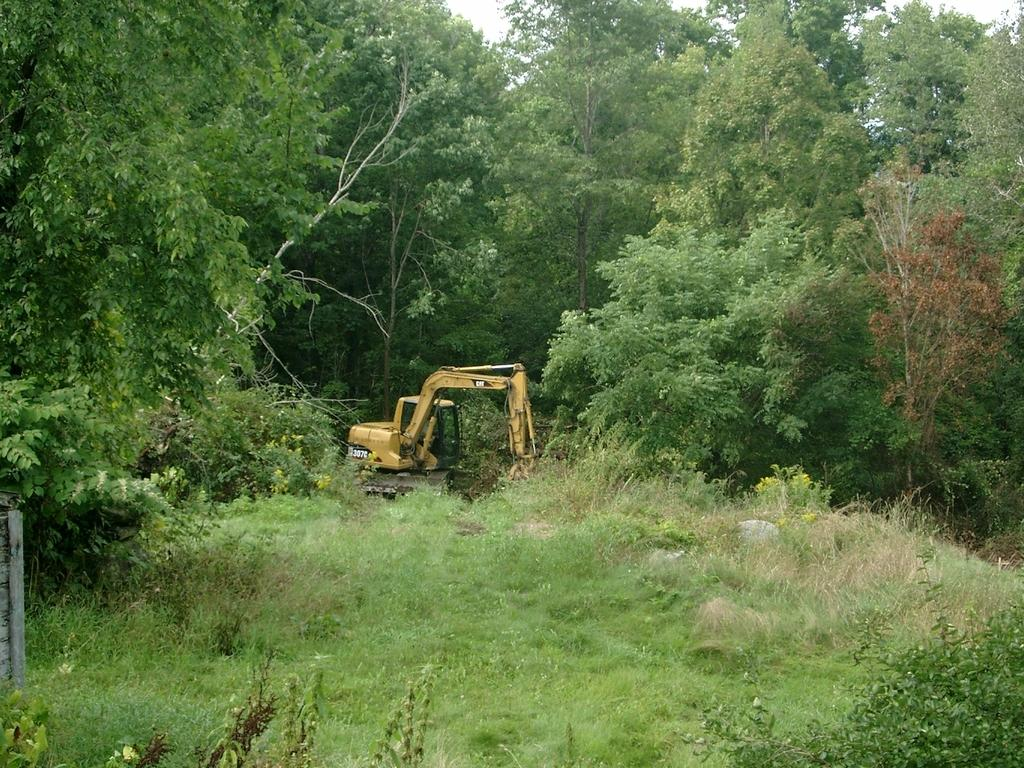What is the main subject in the center of the image? There is a crane in the center of the image. What type of vegetation is at the bottom of the image? There is grass at the bottom of the image. What can be seen in the background of the image? There are trees and the sky visible in the background of the image. How many horses are visible in the image? There are no horses present in the image. What type of chair is being used by the crane in the image? The image does not show a crane, not a person, so there is no chair being used. 